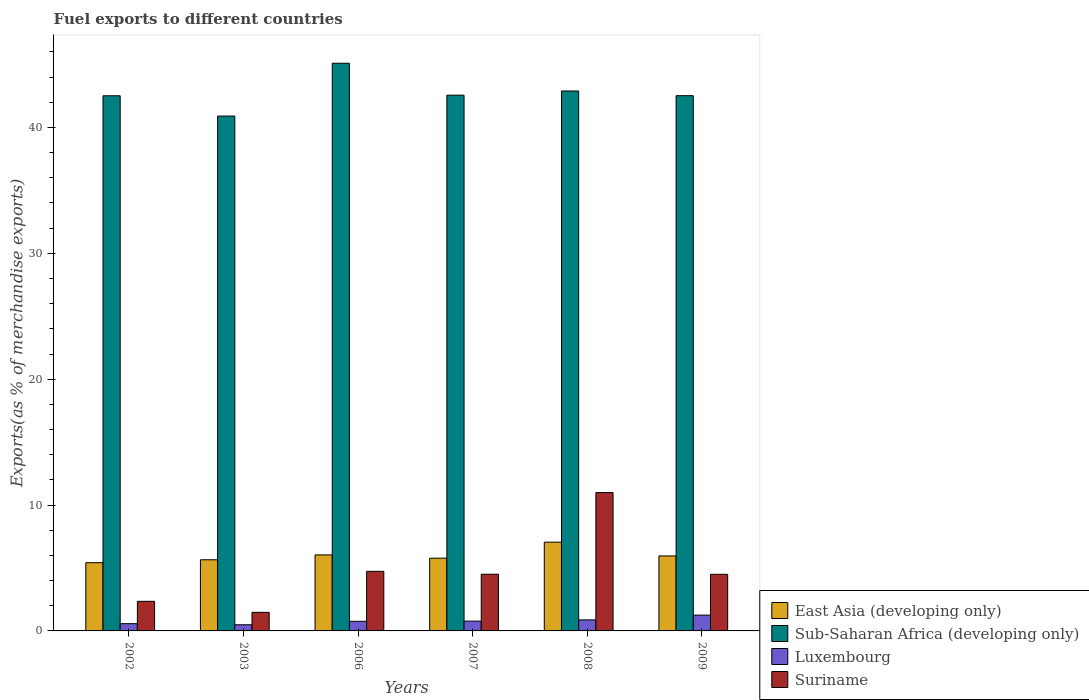Are the number of bars per tick equal to the number of legend labels?
Make the answer very short. Yes. Are the number of bars on each tick of the X-axis equal?
Keep it short and to the point. Yes. How many bars are there on the 1st tick from the right?
Provide a short and direct response. 4. What is the label of the 5th group of bars from the left?
Offer a very short reply. 2008. What is the percentage of exports to different countries in Sub-Saharan Africa (developing only) in 2006?
Offer a terse response. 45.1. Across all years, what is the maximum percentage of exports to different countries in East Asia (developing only)?
Make the answer very short. 7.05. Across all years, what is the minimum percentage of exports to different countries in Sub-Saharan Africa (developing only)?
Make the answer very short. 40.9. In which year was the percentage of exports to different countries in Luxembourg minimum?
Your answer should be very brief. 2003. What is the total percentage of exports to different countries in Suriname in the graph?
Offer a very short reply. 28.55. What is the difference between the percentage of exports to different countries in Suriname in 2003 and that in 2007?
Offer a very short reply. -3.03. What is the difference between the percentage of exports to different countries in Suriname in 2003 and the percentage of exports to different countries in Sub-Saharan Africa (developing only) in 2009?
Keep it short and to the point. -41.05. What is the average percentage of exports to different countries in Sub-Saharan Africa (developing only) per year?
Give a very brief answer. 42.75. In the year 2007, what is the difference between the percentage of exports to different countries in East Asia (developing only) and percentage of exports to different countries in Sub-Saharan Africa (developing only)?
Provide a succinct answer. -36.78. What is the ratio of the percentage of exports to different countries in Suriname in 2007 to that in 2008?
Give a very brief answer. 0.41. What is the difference between the highest and the second highest percentage of exports to different countries in Suriname?
Your response must be concise. 6.26. What is the difference between the highest and the lowest percentage of exports to different countries in Suriname?
Keep it short and to the point. 9.51. In how many years, is the percentage of exports to different countries in Suriname greater than the average percentage of exports to different countries in Suriname taken over all years?
Provide a succinct answer. 1. Is it the case that in every year, the sum of the percentage of exports to different countries in Luxembourg and percentage of exports to different countries in Suriname is greater than the sum of percentage of exports to different countries in East Asia (developing only) and percentage of exports to different countries in Sub-Saharan Africa (developing only)?
Ensure brevity in your answer.  No. What does the 1st bar from the left in 2008 represents?
Offer a terse response. East Asia (developing only). What does the 3rd bar from the right in 2007 represents?
Provide a succinct answer. Sub-Saharan Africa (developing only). How many bars are there?
Ensure brevity in your answer.  24. How many years are there in the graph?
Offer a terse response. 6. Are the values on the major ticks of Y-axis written in scientific E-notation?
Ensure brevity in your answer.  No. Does the graph contain any zero values?
Provide a succinct answer. No. Does the graph contain grids?
Make the answer very short. No. Where does the legend appear in the graph?
Make the answer very short. Bottom right. How many legend labels are there?
Your response must be concise. 4. How are the legend labels stacked?
Ensure brevity in your answer.  Vertical. What is the title of the graph?
Provide a short and direct response. Fuel exports to different countries. Does "Mexico" appear as one of the legend labels in the graph?
Give a very brief answer. No. What is the label or title of the X-axis?
Offer a very short reply. Years. What is the label or title of the Y-axis?
Give a very brief answer. Exports(as % of merchandise exports). What is the Exports(as % of merchandise exports) in East Asia (developing only) in 2002?
Your answer should be compact. 5.42. What is the Exports(as % of merchandise exports) of Sub-Saharan Africa (developing only) in 2002?
Provide a succinct answer. 42.51. What is the Exports(as % of merchandise exports) in Luxembourg in 2002?
Ensure brevity in your answer.  0.58. What is the Exports(as % of merchandise exports) of Suriname in 2002?
Provide a succinct answer. 2.35. What is the Exports(as % of merchandise exports) in East Asia (developing only) in 2003?
Make the answer very short. 5.65. What is the Exports(as % of merchandise exports) of Sub-Saharan Africa (developing only) in 2003?
Your answer should be compact. 40.9. What is the Exports(as % of merchandise exports) in Luxembourg in 2003?
Ensure brevity in your answer.  0.49. What is the Exports(as % of merchandise exports) in Suriname in 2003?
Your answer should be compact. 1.48. What is the Exports(as % of merchandise exports) of East Asia (developing only) in 2006?
Your response must be concise. 6.04. What is the Exports(as % of merchandise exports) of Sub-Saharan Africa (developing only) in 2006?
Provide a short and direct response. 45.1. What is the Exports(as % of merchandise exports) of Luxembourg in 2006?
Provide a short and direct response. 0.76. What is the Exports(as % of merchandise exports) of Suriname in 2006?
Your answer should be very brief. 4.73. What is the Exports(as % of merchandise exports) of East Asia (developing only) in 2007?
Offer a very short reply. 5.78. What is the Exports(as % of merchandise exports) in Sub-Saharan Africa (developing only) in 2007?
Offer a terse response. 42.56. What is the Exports(as % of merchandise exports) of Luxembourg in 2007?
Provide a succinct answer. 0.78. What is the Exports(as % of merchandise exports) in Suriname in 2007?
Your response must be concise. 4.5. What is the Exports(as % of merchandise exports) in East Asia (developing only) in 2008?
Ensure brevity in your answer.  7.05. What is the Exports(as % of merchandise exports) in Sub-Saharan Africa (developing only) in 2008?
Your answer should be compact. 42.89. What is the Exports(as % of merchandise exports) of Luxembourg in 2008?
Provide a short and direct response. 0.88. What is the Exports(as % of merchandise exports) of Suriname in 2008?
Keep it short and to the point. 10.99. What is the Exports(as % of merchandise exports) in East Asia (developing only) in 2009?
Keep it short and to the point. 5.96. What is the Exports(as % of merchandise exports) in Sub-Saharan Africa (developing only) in 2009?
Provide a short and direct response. 42.52. What is the Exports(as % of merchandise exports) in Luxembourg in 2009?
Your answer should be very brief. 1.26. What is the Exports(as % of merchandise exports) in Suriname in 2009?
Your response must be concise. 4.5. Across all years, what is the maximum Exports(as % of merchandise exports) of East Asia (developing only)?
Make the answer very short. 7.05. Across all years, what is the maximum Exports(as % of merchandise exports) of Sub-Saharan Africa (developing only)?
Provide a short and direct response. 45.1. Across all years, what is the maximum Exports(as % of merchandise exports) in Luxembourg?
Your response must be concise. 1.26. Across all years, what is the maximum Exports(as % of merchandise exports) in Suriname?
Provide a succinct answer. 10.99. Across all years, what is the minimum Exports(as % of merchandise exports) in East Asia (developing only)?
Provide a short and direct response. 5.42. Across all years, what is the minimum Exports(as % of merchandise exports) of Sub-Saharan Africa (developing only)?
Provide a short and direct response. 40.9. Across all years, what is the minimum Exports(as % of merchandise exports) of Luxembourg?
Keep it short and to the point. 0.49. Across all years, what is the minimum Exports(as % of merchandise exports) of Suriname?
Offer a very short reply. 1.48. What is the total Exports(as % of merchandise exports) in East Asia (developing only) in the graph?
Provide a succinct answer. 35.9. What is the total Exports(as % of merchandise exports) in Sub-Saharan Africa (developing only) in the graph?
Offer a very short reply. 256.49. What is the total Exports(as % of merchandise exports) of Luxembourg in the graph?
Offer a terse response. 4.74. What is the total Exports(as % of merchandise exports) of Suriname in the graph?
Ensure brevity in your answer.  28.55. What is the difference between the Exports(as % of merchandise exports) of East Asia (developing only) in 2002 and that in 2003?
Give a very brief answer. -0.23. What is the difference between the Exports(as % of merchandise exports) of Sub-Saharan Africa (developing only) in 2002 and that in 2003?
Make the answer very short. 1.61. What is the difference between the Exports(as % of merchandise exports) of Luxembourg in 2002 and that in 2003?
Provide a short and direct response. 0.09. What is the difference between the Exports(as % of merchandise exports) of Suriname in 2002 and that in 2003?
Your response must be concise. 0.87. What is the difference between the Exports(as % of merchandise exports) in East Asia (developing only) in 2002 and that in 2006?
Offer a terse response. -0.62. What is the difference between the Exports(as % of merchandise exports) in Sub-Saharan Africa (developing only) in 2002 and that in 2006?
Offer a terse response. -2.58. What is the difference between the Exports(as % of merchandise exports) of Luxembourg in 2002 and that in 2006?
Give a very brief answer. -0.19. What is the difference between the Exports(as % of merchandise exports) in Suriname in 2002 and that in 2006?
Provide a short and direct response. -2.38. What is the difference between the Exports(as % of merchandise exports) in East Asia (developing only) in 2002 and that in 2007?
Give a very brief answer. -0.36. What is the difference between the Exports(as % of merchandise exports) of Sub-Saharan Africa (developing only) in 2002 and that in 2007?
Offer a very short reply. -0.05. What is the difference between the Exports(as % of merchandise exports) of Luxembourg in 2002 and that in 2007?
Provide a succinct answer. -0.2. What is the difference between the Exports(as % of merchandise exports) in Suriname in 2002 and that in 2007?
Make the answer very short. -2.15. What is the difference between the Exports(as % of merchandise exports) in East Asia (developing only) in 2002 and that in 2008?
Ensure brevity in your answer.  -1.63. What is the difference between the Exports(as % of merchandise exports) of Sub-Saharan Africa (developing only) in 2002 and that in 2008?
Provide a short and direct response. -0.38. What is the difference between the Exports(as % of merchandise exports) of Luxembourg in 2002 and that in 2008?
Your response must be concise. -0.3. What is the difference between the Exports(as % of merchandise exports) in Suriname in 2002 and that in 2008?
Provide a short and direct response. -8.64. What is the difference between the Exports(as % of merchandise exports) in East Asia (developing only) in 2002 and that in 2009?
Offer a very short reply. -0.54. What is the difference between the Exports(as % of merchandise exports) of Sub-Saharan Africa (developing only) in 2002 and that in 2009?
Keep it short and to the point. -0.01. What is the difference between the Exports(as % of merchandise exports) of Luxembourg in 2002 and that in 2009?
Make the answer very short. -0.68. What is the difference between the Exports(as % of merchandise exports) in Suriname in 2002 and that in 2009?
Make the answer very short. -2.15. What is the difference between the Exports(as % of merchandise exports) of East Asia (developing only) in 2003 and that in 2006?
Your response must be concise. -0.39. What is the difference between the Exports(as % of merchandise exports) of Sub-Saharan Africa (developing only) in 2003 and that in 2006?
Provide a succinct answer. -4.2. What is the difference between the Exports(as % of merchandise exports) of Luxembourg in 2003 and that in 2006?
Offer a very short reply. -0.28. What is the difference between the Exports(as % of merchandise exports) of Suriname in 2003 and that in 2006?
Offer a very short reply. -3.26. What is the difference between the Exports(as % of merchandise exports) in East Asia (developing only) in 2003 and that in 2007?
Offer a terse response. -0.13. What is the difference between the Exports(as % of merchandise exports) in Sub-Saharan Africa (developing only) in 2003 and that in 2007?
Provide a short and direct response. -1.66. What is the difference between the Exports(as % of merchandise exports) in Luxembourg in 2003 and that in 2007?
Give a very brief answer. -0.29. What is the difference between the Exports(as % of merchandise exports) in Suriname in 2003 and that in 2007?
Ensure brevity in your answer.  -3.03. What is the difference between the Exports(as % of merchandise exports) of East Asia (developing only) in 2003 and that in 2008?
Offer a terse response. -1.4. What is the difference between the Exports(as % of merchandise exports) in Sub-Saharan Africa (developing only) in 2003 and that in 2008?
Offer a terse response. -1.99. What is the difference between the Exports(as % of merchandise exports) of Luxembourg in 2003 and that in 2008?
Your answer should be very brief. -0.39. What is the difference between the Exports(as % of merchandise exports) in Suriname in 2003 and that in 2008?
Give a very brief answer. -9.51. What is the difference between the Exports(as % of merchandise exports) in East Asia (developing only) in 2003 and that in 2009?
Offer a terse response. -0.3. What is the difference between the Exports(as % of merchandise exports) in Sub-Saharan Africa (developing only) in 2003 and that in 2009?
Your response must be concise. -1.62. What is the difference between the Exports(as % of merchandise exports) of Luxembourg in 2003 and that in 2009?
Provide a short and direct response. -0.77. What is the difference between the Exports(as % of merchandise exports) of Suriname in 2003 and that in 2009?
Give a very brief answer. -3.02. What is the difference between the Exports(as % of merchandise exports) of East Asia (developing only) in 2006 and that in 2007?
Your response must be concise. 0.26. What is the difference between the Exports(as % of merchandise exports) of Sub-Saharan Africa (developing only) in 2006 and that in 2007?
Ensure brevity in your answer.  2.54. What is the difference between the Exports(as % of merchandise exports) in Luxembourg in 2006 and that in 2007?
Your response must be concise. -0.01. What is the difference between the Exports(as % of merchandise exports) in Suriname in 2006 and that in 2007?
Provide a short and direct response. 0.23. What is the difference between the Exports(as % of merchandise exports) of East Asia (developing only) in 2006 and that in 2008?
Your answer should be compact. -1.01. What is the difference between the Exports(as % of merchandise exports) of Sub-Saharan Africa (developing only) in 2006 and that in 2008?
Offer a very short reply. 2.2. What is the difference between the Exports(as % of merchandise exports) in Luxembourg in 2006 and that in 2008?
Offer a very short reply. -0.11. What is the difference between the Exports(as % of merchandise exports) of Suriname in 2006 and that in 2008?
Your answer should be very brief. -6.26. What is the difference between the Exports(as % of merchandise exports) of East Asia (developing only) in 2006 and that in 2009?
Give a very brief answer. 0.08. What is the difference between the Exports(as % of merchandise exports) of Sub-Saharan Africa (developing only) in 2006 and that in 2009?
Offer a very short reply. 2.58. What is the difference between the Exports(as % of merchandise exports) of Luxembourg in 2006 and that in 2009?
Ensure brevity in your answer.  -0.49. What is the difference between the Exports(as % of merchandise exports) in Suriname in 2006 and that in 2009?
Keep it short and to the point. 0.24. What is the difference between the Exports(as % of merchandise exports) in East Asia (developing only) in 2007 and that in 2008?
Make the answer very short. -1.27. What is the difference between the Exports(as % of merchandise exports) in Sub-Saharan Africa (developing only) in 2007 and that in 2008?
Give a very brief answer. -0.33. What is the difference between the Exports(as % of merchandise exports) in Luxembourg in 2007 and that in 2008?
Your answer should be compact. -0.1. What is the difference between the Exports(as % of merchandise exports) in Suriname in 2007 and that in 2008?
Provide a short and direct response. -6.49. What is the difference between the Exports(as % of merchandise exports) of East Asia (developing only) in 2007 and that in 2009?
Offer a very short reply. -0.18. What is the difference between the Exports(as % of merchandise exports) of Sub-Saharan Africa (developing only) in 2007 and that in 2009?
Make the answer very short. 0.04. What is the difference between the Exports(as % of merchandise exports) in Luxembourg in 2007 and that in 2009?
Your answer should be very brief. -0.48. What is the difference between the Exports(as % of merchandise exports) of Suriname in 2007 and that in 2009?
Keep it short and to the point. 0.01. What is the difference between the Exports(as % of merchandise exports) of East Asia (developing only) in 2008 and that in 2009?
Keep it short and to the point. 1.1. What is the difference between the Exports(as % of merchandise exports) in Sub-Saharan Africa (developing only) in 2008 and that in 2009?
Make the answer very short. 0.37. What is the difference between the Exports(as % of merchandise exports) in Luxembourg in 2008 and that in 2009?
Offer a terse response. -0.38. What is the difference between the Exports(as % of merchandise exports) in Suriname in 2008 and that in 2009?
Your answer should be compact. 6.49. What is the difference between the Exports(as % of merchandise exports) in East Asia (developing only) in 2002 and the Exports(as % of merchandise exports) in Sub-Saharan Africa (developing only) in 2003?
Keep it short and to the point. -35.48. What is the difference between the Exports(as % of merchandise exports) in East Asia (developing only) in 2002 and the Exports(as % of merchandise exports) in Luxembourg in 2003?
Your response must be concise. 4.93. What is the difference between the Exports(as % of merchandise exports) of East Asia (developing only) in 2002 and the Exports(as % of merchandise exports) of Suriname in 2003?
Your response must be concise. 3.94. What is the difference between the Exports(as % of merchandise exports) in Sub-Saharan Africa (developing only) in 2002 and the Exports(as % of merchandise exports) in Luxembourg in 2003?
Provide a short and direct response. 42.03. What is the difference between the Exports(as % of merchandise exports) in Sub-Saharan Africa (developing only) in 2002 and the Exports(as % of merchandise exports) in Suriname in 2003?
Provide a succinct answer. 41.04. What is the difference between the Exports(as % of merchandise exports) in Luxembourg in 2002 and the Exports(as % of merchandise exports) in Suriname in 2003?
Make the answer very short. -0.9. What is the difference between the Exports(as % of merchandise exports) in East Asia (developing only) in 2002 and the Exports(as % of merchandise exports) in Sub-Saharan Africa (developing only) in 2006?
Keep it short and to the point. -39.68. What is the difference between the Exports(as % of merchandise exports) of East Asia (developing only) in 2002 and the Exports(as % of merchandise exports) of Luxembourg in 2006?
Your answer should be compact. 4.66. What is the difference between the Exports(as % of merchandise exports) in East Asia (developing only) in 2002 and the Exports(as % of merchandise exports) in Suriname in 2006?
Keep it short and to the point. 0.69. What is the difference between the Exports(as % of merchandise exports) of Sub-Saharan Africa (developing only) in 2002 and the Exports(as % of merchandise exports) of Luxembourg in 2006?
Give a very brief answer. 41.75. What is the difference between the Exports(as % of merchandise exports) of Sub-Saharan Africa (developing only) in 2002 and the Exports(as % of merchandise exports) of Suriname in 2006?
Your answer should be very brief. 37.78. What is the difference between the Exports(as % of merchandise exports) of Luxembourg in 2002 and the Exports(as % of merchandise exports) of Suriname in 2006?
Offer a terse response. -4.16. What is the difference between the Exports(as % of merchandise exports) in East Asia (developing only) in 2002 and the Exports(as % of merchandise exports) in Sub-Saharan Africa (developing only) in 2007?
Your answer should be very brief. -37.14. What is the difference between the Exports(as % of merchandise exports) in East Asia (developing only) in 2002 and the Exports(as % of merchandise exports) in Luxembourg in 2007?
Provide a succinct answer. 4.64. What is the difference between the Exports(as % of merchandise exports) in East Asia (developing only) in 2002 and the Exports(as % of merchandise exports) in Suriname in 2007?
Offer a very short reply. 0.92. What is the difference between the Exports(as % of merchandise exports) in Sub-Saharan Africa (developing only) in 2002 and the Exports(as % of merchandise exports) in Luxembourg in 2007?
Ensure brevity in your answer.  41.74. What is the difference between the Exports(as % of merchandise exports) in Sub-Saharan Africa (developing only) in 2002 and the Exports(as % of merchandise exports) in Suriname in 2007?
Provide a short and direct response. 38.01. What is the difference between the Exports(as % of merchandise exports) of Luxembourg in 2002 and the Exports(as % of merchandise exports) of Suriname in 2007?
Keep it short and to the point. -3.93. What is the difference between the Exports(as % of merchandise exports) of East Asia (developing only) in 2002 and the Exports(as % of merchandise exports) of Sub-Saharan Africa (developing only) in 2008?
Offer a very short reply. -37.47. What is the difference between the Exports(as % of merchandise exports) of East Asia (developing only) in 2002 and the Exports(as % of merchandise exports) of Luxembourg in 2008?
Ensure brevity in your answer.  4.54. What is the difference between the Exports(as % of merchandise exports) of East Asia (developing only) in 2002 and the Exports(as % of merchandise exports) of Suriname in 2008?
Offer a terse response. -5.57. What is the difference between the Exports(as % of merchandise exports) in Sub-Saharan Africa (developing only) in 2002 and the Exports(as % of merchandise exports) in Luxembourg in 2008?
Offer a very short reply. 41.64. What is the difference between the Exports(as % of merchandise exports) of Sub-Saharan Africa (developing only) in 2002 and the Exports(as % of merchandise exports) of Suriname in 2008?
Give a very brief answer. 31.52. What is the difference between the Exports(as % of merchandise exports) of Luxembourg in 2002 and the Exports(as % of merchandise exports) of Suriname in 2008?
Your answer should be very brief. -10.41. What is the difference between the Exports(as % of merchandise exports) in East Asia (developing only) in 2002 and the Exports(as % of merchandise exports) in Sub-Saharan Africa (developing only) in 2009?
Ensure brevity in your answer.  -37.1. What is the difference between the Exports(as % of merchandise exports) of East Asia (developing only) in 2002 and the Exports(as % of merchandise exports) of Luxembourg in 2009?
Your response must be concise. 4.16. What is the difference between the Exports(as % of merchandise exports) of East Asia (developing only) in 2002 and the Exports(as % of merchandise exports) of Suriname in 2009?
Give a very brief answer. 0.92. What is the difference between the Exports(as % of merchandise exports) of Sub-Saharan Africa (developing only) in 2002 and the Exports(as % of merchandise exports) of Luxembourg in 2009?
Your answer should be very brief. 41.26. What is the difference between the Exports(as % of merchandise exports) of Sub-Saharan Africa (developing only) in 2002 and the Exports(as % of merchandise exports) of Suriname in 2009?
Offer a terse response. 38.02. What is the difference between the Exports(as % of merchandise exports) of Luxembourg in 2002 and the Exports(as % of merchandise exports) of Suriname in 2009?
Provide a succinct answer. -3.92. What is the difference between the Exports(as % of merchandise exports) of East Asia (developing only) in 2003 and the Exports(as % of merchandise exports) of Sub-Saharan Africa (developing only) in 2006?
Keep it short and to the point. -39.45. What is the difference between the Exports(as % of merchandise exports) in East Asia (developing only) in 2003 and the Exports(as % of merchandise exports) in Luxembourg in 2006?
Your answer should be compact. 4.89. What is the difference between the Exports(as % of merchandise exports) in East Asia (developing only) in 2003 and the Exports(as % of merchandise exports) in Suriname in 2006?
Your answer should be compact. 0.92. What is the difference between the Exports(as % of merchandise exports) of Sub-Saharan Africa (developing only) in 2003 and the Exports(as % of merchandise exports) of Luxembourg in 2006?
Your response must be concise. 40.14. What is the difference between the Exports(as % of merchandise exports) in Sub-Saharan Africa (developing only) in 2003 and the Exports(as % of merchandise exports) in Suriname in 2006?
Offer a terse response. 36.17. What is the difference between the Exports(as % of merchandise exports) of Luxembourg in 2003 and the Exports(as % of merchandise exports) of Suriname in 2006?
Your response must be concise. -4.25. What is the difference between the Exports(as % of merchandise exports) of East Asia (developing only) in 2003 and the Exports(as % of merchandise exports) of Sub-Saharan Africa (developing only) in 2007?
Offer a very short reply. -36.91. What is the difference between the Exports(as % of merchandise exports) in East Asia (developing only) in 2003 and the Exports(as % of merchandise exports) in Luxembourg in 2007?
Your answer should be very brief. 4.87. What is the difference between the Exports(as % of merchandise exports) of East Asia (developing only) in 2003 and the Exports(as % of merchandise exports) of Suriname in 2007?
Provide a succinct answer. 1.15. What is the difference between the Exports(as % of merchandise exports) in Sub-Saharan Africa (developing only) in 2003 and the Exports(as % of merchandise exports) in Luxembourg in 2007?
Offer a very short reply. 40.12. What is the difference between the Exports(as % of merchandise exports) of Sub-Saharan Africa (developing only) in 2003 and the Exports(as % of merchandise exports) of Suriname in 2007?
Give a very brief answer. 36.4. What is the difference between the Exports(as % of merchandise exports) of Luxembourg in 2003 and the Exports(as % of merchandise exports) of Suriname in 2007?
Offer a terse response. -4.02. What is the difference between the Exports(as % of merchandise exports) in East Asia (developing only) in 2003 and the Exports(as % of merchandise exports) in Sub-Saharan Africa (developing only) in 2008?
Provide a short and direct response. -37.24. What is the difference between the Exports(as % of merchandise exports) of East Asia (developing only) in 2003 and the Exports(as % of merchandise exports) of Luxembourg in 2008?
Offer a very short reply. 4.78. What is the difference between the Exports(as % of merchandise exports) in East Asia (developing only) in 2003 and the Exports(as % of merchandise exports) in Suriname in 2008?
Give a very brief answer. -5.34. What is the difference between the Exports(as % of merchandise exports) of Sub-Saharan Africa (developing only) in 2003 and the Exports(as % of merchandise exports) of Luxembourg in 2008?
Ensure brevity in your answer.  40.03. What is the difference between the Exports(as % of merchandise exports) of Sub-Saharan Africa (developing only) in 2003 and the Exports(as % of merchandise exports) of Suriname in 2008?
Your response must be concise. 29.91. What is the difference between the Exports(as % of merchandise exports) in Luxembourg in 2003 and the Exports(as % of merchandise exports) in Suriname in 2008?
Give a very brief answer. -10.5. What is the difference between the Exports(as % of merchandise exports) in East Asia (developing only) in 2003 and the Exports(as % of merchandise exports) in Sub-Saharan Africa (developing only) in 2009?
Keep it short and to the point. -36.87. What is the difference between the Exports(as % of merchandise exports) of East Asia (developing only) in 2003 and the Exports(as % of merchandise exports) of Luxembourg in 2009?
Your response must be concise. 4.4. What is the difference between the Exports(as % of merchandise exports) in East Asia (developing only) in 2003 and the Exports(as % of merchandise exports) in Suriname in 2009?
Your answer should be compact. 1.15. What is the difference between the Exports(as % of merchandise exports) of Sub-Saharan Africa (developing only) in 2003 and the Exports(as % of merchandise exports) of Luxembourg in 2009?
Offer a terse response. 39.65. What is the difference between the Exports(as % of merchandise exports) in Sub-Saharan Africa (developing only) in 2003 and the Exports(as % of merchandise exports) in Suriname in 2009?
Give a very brief answer. 36.41. What is the difference between the Exports(as % of merchandise exports) of Luxembourg in 2003 and the Exports(as % of merchandise exports) of Suriname in 2009?
Your response must be concise. -4.01. What is the difference between the Exports(as % of merchandise exports) in East Asia (developing only) in 2006 and the Exports(as % of merchandise exports) in Sub-Saharan Africa (developing only) in 2007?
Your response must be concise. -36.52. What is the difference between the Exports(as % of merchandise exports) of East Asia (developing only) in 2006 and the Exports(as % of merchandise exports) of Luxembourg in 2007?
Provide a succinct answer. 5.26. What is the difference between the Exports(as % of merchandise exports) of East Asia (developing only) in 2006 and the Exports(as % of merchandise exports) of Suriname in 2007?
Ensure brevity in your answer.  1.54. What is the difference between the Exports(as % of merchandise exports) in Sub-Saharan Africa (developing only) in 2006 and the Exports(as % of merchandise exports) in Luxembourg in 2007?
Give a very brief answer. 44.32. What is the difference between the Exports(as % of merchandise exports) of Sub-Saharan Africa (developing only) in 2006 and the Exports(as % of merchandise exports) of Suriname in 2007?
Your response must be concise. 40.59. What is the difference between the Exports(as % of merchandise exports) in Luxembourg in 2006 and the Exports(as % of merchandise exports) in Suriname in 2007?
Your answer should be compact. -3.74. What is the difference between the Exports(as % of merchandise exports) in East Asia (developing only) in 2006 and the Exports(as % of merchandise exports) in Sub-Saharan Africa (developing only) in 2008?
Offer a very short reply. -36.86. What is the difference between the Exports(as % of merchandise exports) of East Asia (developing only) in 2006 and the Exports(as % of merchandise exports) of Luxembourg in 2008?
Provide a succinct answer. 5.16. What is the difference between the Exports(as % of merchandise exports) in East Asia (developing only) in 2006 and the Exports(as % of merchandise exports) in Suriname in 2008?
Make the answer very short. -4.95. What is the difference between the Exports(as % of merchandise exports) in Sub-Saharan Africa (developing only) in 2006 and the Exports(as % of merchandise exports) in Luxembourg in 2008?
Your answer should be very brief. 44.22. What is the difference between the Exports(as % of merchandise exports) in Sub-Saharan Africa (developing only) in 2006 and the Exports(as % of merchandise exports) in Suriname in 2008?
Ensure brevity in your answer.  34.11. What is the difference between the Exports(as % of merchandise exports) of Luxembourg in 2006 and the Exports(as % of merchandise exports) of Suriname in 2008?
Offer a terse response. -10.23. What is the difference between the Exports(as % of merchandise exports) of East Asia (developing only) in 2006 and the Exports(as % of merchandise exports) of Sub-Saharan Africa (developing only) in 2009?
Your answer should be compact. -36.48. What is the difference between the Exports(as % of merchandise exports) of East Asia (developing only) in 2006 and the Exports(as % of merchandise exports) of Luxembourg in 2009?
Give a very brief answer. 4.78. What is the difference between the Exports(as % of merchandise exports) in East Asia (developing only) in 2006 and the Exports(as % of merchandise exports) in Suriname in 2009?
Your answer should be compact. 1.54. What is the difference between the Exports(as % of merchandise exports) in Sub-Saharan Africa (developing only) in 2006 and the Exports(as % of merchandise exports) in Luxembourg in 2009?
Keep it short and to the point. 43.84. What is the difference between the Exports(as % of merchandise exports) of Sub-Saharan Africa (developing only) in 2006 and the Exports(as % of merchandise exports) of Suriname in 2009?
Offer a very short reply. 40.6. What is the difference between the Exports(as % of merchandise exports) of Luxembourg in 2006 and the Exports(as % of merchandise exports) of Suriname in 2009?
Give a very brief answer. -3.73. What is the difference between the Exports(as % of merchandise exports) of East Asia (developing only) in 2007 and the Exports(as % of merchandise exports) of Sub-Saharan Africa (developing only) in 2008?
Provide a short and direct response. -37.12. What is the difference between the Exports(as % of merchandise exports) in East Asia (developing only) in 2007 and the Exports(as % of merchandise exports) in Luxembourg in 2008?
Make the answer very short. 4.9. What is the difference between the Exports(as % of merchandise exports) in East Asia (developing only) in 2007 and the Exports(as % of merchandise exports) in Suriname in 2008?
Offer a terse response. -5.21. What is the difference between the Exports(as % of merchandise exports) of Sub-Saharan Africa (developing only) in 2007 and the Exports(as % of merchandise exports) of Luxembourg in 2008?
Provide a short and direct response. 41.69. What is the difference between the Exports(as % of merchandise exports) in Sub-Saharan Africa (developing only) in 2007 and the Exports(as % of merchandise exports) in Suriname in 2008?
Your answer should be very brief. 31.57. What is the difference between the Exports(as % of merchandise exports) of Luxembourg in 2007 and the Exports(as % of merchandise exports) of Suriname in 2008?
Your response must be concise. -10.21. What is the difference between the Exports(as % of merchandise exports) in East Asia (developing only) in 2007 and the Exports(as % of merchandise exports) in Sub-Saharan Africa (developing only) in 2009?
Make the answer very short. -36.74. What is the difference between the Exports(as % of merchandise exports) of East Asia (developing only) in 2007 and the Exports(as % of merchandise exports) of Luxembourg in 2009?
Offer a very short reply. 4.52. What is the difference between the Exports(as % of merchandise exports) in East Asia (developing only) in 2007 and the Exports(as % of merchandise exports) in Suriname in 2009?
Offer a terse response. 1.28. What is the difference between the Exports(as % of merchandise exports) of Sub-Saharan Africa (developing only) in 2007 and the Exports(as % of merchandise exports) of Luxembourg in 2009?
Provide a succinct answer. 41.31. What is the difference between the Exports(as % of merchandise exports) of Sub-Saharan Africa (developing only) in 2007 and the Exports(as % of merchandise exports) of Suriname in 2009?
Give a very brief answer. 38.06. What is the difference between the Exports(as % of merchandise exports) of Luxembourg in 2007 and the Exports(as % of merchandise exports) of Suriname in 2009?
Ensure brevity in your answer.  -3.72. What is the difference between the Exports(as % of merchandise exports) of East Asia (developing only) in 2008 and the Exports(as % of merchandise exports) of Sub-Saharan Africa (developing only) in 2009?
Your answer should be compact. -35.47. What is the difference between the Exports(as % of merchandise exports) of East Asia (developing only) in 2008 and the Exports(as % of merchandise exports) of Luxembourg in 2009?
Provide a succinct answer. 5.8. What is the difference between the Exports(as % of merchandise exports) in East Asia (developing only) in 2008 and the Exports(as % of merchandise exports) in Suriname in 2009?
Keep it short and to the point. 2.56. What is the difference between the Exports(as % of merchandise exports) of Sub-Saharan Africa (developing only) in 2008 and the Exports(as % of merchandise exports) of Luxembourg in 2009?
Your answer should be compact. 41.64. What is the difference between the Exports(as % of merchandise exports) of Sub-Saharan Africa (developing only) in 2008 and the Exports(as % of merchandise exports) of Suriname in 2009?
Make the answer very short. 38.4. What is the difference between the Exports(as % of merchandise exports) in Luxembourg in 2008 and the Exports(as % of merchandise exports) in Suriname in 2009?
Your answer should be very brief. -3.62. What is the average Exports(as % of merchandise exports) of East Asia (developing only) per year?
Provide a succinct answer. 5.98. What is the average Exports(as % of merchandise exports) of Sub-Saharan Africa (developing only) per year?
Your answer should be compact. 42.75. What is the average Exports(as % of merchandise exports) of Luxembourg per year?
Offer a terse response. 0.79. What is the average Exports(as % of merchandise exports) in Suriname per year?
Ensure brevity in your answer.  4.76. In the year 2002, what is the difference between the Exports(as % of merchandise exports) in East Asia (developing only) and Exports(as % of merchandise exports) in Sub-Saharan Africa (developing only)?
Keep it short and to the point. -37.1. In the year 2002, what is the difference between the Exports(as % of merchandise exports) of East Asia (developing only) and Exports(as % of merchandise exports) of Luxembourg?
Give a very brief answer. 4.84. In the year 2002, what is the difference between the Exports(as % of merchandise exports) in East Asia (developing only) and Exports(as % of merchandise exports) in Suriname?
Your response must be concise. 3.07. In the year 2002, what is the difference between the Exports(as % of merchandise exports) in Sub-Saharan Africa (developing only) and Exports(as % of merchandise exports) in Luxembourg?
Give a very brief answer. 41.94. In the year 2002, what is the difference between the Exports(as % of merchandise exports) of Sub-Saharan Africa (developing only) and Exports(as % of merchandise exports) of Suriname?
Provide a succinct answer. 40.16. In the year 2002, what is the difference between the Exports(as % of merchandise exports) in Luxembourg and Exports(as % of merchandise exports) in Suriname?
Your answer should be very brief. -1.77. In the year 2003, what is the difference between the Exports(as % of merchandise exports) of East Asia (developing only) and Exports(as % of merchandise exports) of Sub-Saharan Africa (developing only)?
Give a very brief answer. -35.25. In the year 2003, what is the difference between the Exports(as % of merchandise exports) in East Asia (developing only) and Exports(as % of merchandise exports) in Luxembourg?
Provide a succinct answer. 5.16. In the year 2003, what is the difference between the Exports(as % of merchandise exports) of East Asia (developing only) and Exports(as % of merchandise exports) of Suriname?
Make the answer very short. 4.18. In the year 2003, what is the difference between the Exports(as % of merchandise exports) of Sub-Saharan Africa (developing only) and Exports(as % of merchandise exports) of Luxembourg?
Your answer should be compact. 40.41. In the year 2003, what is the difference between the Exports(as % of merchandise exports) in Sub-Saharan Africa (developing only) and Exports(as % of merchandise exports) in Suriname?
Provide a short and direct response. 39.43. In the year 2003, what is the difference between the Exports(as % of merchandise exports) of Luxembourg and Exports(as % of merchandise exports) of Suriname?
Make the answer very short. -0.99. In the year 2006, what is the difference between the Exports(as % of merchandise exports) of East Asia (developing only) and Exports(as % of merchandise exports) of Sub-Saharan Africa (developing only)?
Your response must be concise. -39.06. In the year 2006, what is the difference between the Exports(as % of merchandise exports) in East Asia (developing only) and Exports(as % of merchandise exports) in Luxembourg?
Make the answer very short. 5.27. In the year 2006, what is the difference between the Exports(as % of merchandise exports) of East Asia (developing only) and Exports(as % of merchandise exports) of Suriname?
Offer a very short reply. 1.3. In the year 2006, what is the difference between the Exports(as % of merchandise exports) of Sub-Saharan Africa (developing only) and Exports(as % of merchandise exports) of Luxembourg?
Your answer should be very brief. 44.33. In the year 2006, what is the difference between the Exports(as % of merchandise exports) in Sub-Saharan Africa (developing only) and Exports(as % of merchandise exports) in Suriname?
Offer a very short reply. 40.36. In the year 2006, what is the difference between the Exports(as % of merchandise exports) of Luxembourg and Exports(as % of merchandise exports) of Suriname?
Ensure brevity in your answer.  -3.97. In the year 2007, what is the difference between the Exports(as % of merchandise exports) of East Asia (developing only) and Exports(as % of merchandise exports) of Sub-Saharan Africa (developing only)?
Keep it short and to the point. -36.78. In the year 2007, what is the difference between the Exports(as % of merchandise exports) in East Asia (developing only) and Exports(as % of merchandise exports) in Luxembourg?
Provide a short and direct response. 5. In the year 2007, what is the difference between the Exports(as % of merchandise exports) of East Asia (developing only) and Exports(as % of merchandise exports) of Suriname?
Your answer should be very brief. 1.28. In the year 2007, what is the difference between the Exports(as % of merchandise exports) of Sub-Saharan Africa (developing only) and Exports(as % of merchandise exports) of Luxembourg?
Give a very brief answer. 41.78. In the year 2007, what is the difference between the Exports(as % of merchandise exports) of Sub-Saharan Africa (developing only) and Exports(as % of merchandise exports) of Suriname?
Make the answer very short. 38.06. In the year 2007, what is the difference between the Exports(as % of merchandise exports) of Luxembourg and Exports(as % of merchandise exports) of Suriname?
Your response must be concise. -3.72. In the year 2008, what is the difference between the Exports(as % of merchandise exports) in East Asia (developing only) and Exports(as % of merchandise exports) in Sub-Saharan Africa (developing only)?
Your response must be concise. -35.84. In the year 2008, what is the difference between the Exports(as % of merchandise exports) in East Asia (developing only) and Exports(as % of merchandise exports) in Luxembourg?
Give a very brief answer. 6.18. In the year 2008, what is the difference between the Exports(as % of merchandise exports) of East Asia (developing only) and Exports(as % of merchandise exports) of Suriname?
Your answer should be compact. -3.94. In the year 2008, what is the difference between the Exports(as % of merchandise exports) in Sub-Saharan Africa (developing only) and Exports(as % of merchandise exports) in Luxembourg?
Make the answer very short. 42.02. In the year 2008, what is the difference between the Exports(as % of merchandise exports) of Sub-Saharan Africa (developing only) and Exports(as % of merchandise exports) of Suriname?
Give a very brief answer. 31.9. In the year 2008, what is the difference between the Exports(as % of merchandise exports) in Luxembourg and Exports(as % of merchandise exports) in Suriname?
Ensure brevity in your answer.  -10.11. In the year 2009, what is the difference between the Exports(as % of merchandise exports) in East Asia (developing only) and Exports(as % of merchandise exports) in Sub-Saharan Africa (developing only)?
Keep it short and to the point. -36.57. In the year 2009, what is the difference between the Exports(as % of merchandise exports) of East Asia (developing only) and Exports(as % of merchandise exports) of Luxembourg?
Offer a terse response. 4.7. In the year 2009, what is the difference between the Exports(as % of merchandise exports) of East Asia (developing only) and Exports(as % of merchandise exports) of Suriname?
Your answer should be compact. 1.46. In the year 2009, what is the difference between the Exports(as % of merchandise exports) in Sub-Saharan Africa (developing only) and Exports(as % of merchandise exports) in Luxembourg?
Provide a succinct answer. 41.27. In the year 2009, what is the difference between the Exports(as % of merchandise exports) in Sub-Saharan Africa (developing only) and Exports(as % of merchandise exports) in Suriname?
Offer a very short reply. 38.02. In the year 2009, what is the difference between the Exports(as % of merchandise exports) in Luxembourg and Exports(as % of merchandise exports) in Suriname?
Offer a terse response. -3.24. What is the ratio of the Exports(as % of merchandise exports) of East Asia (developing only) in 2002 to that in 2003?
Provide a succinct answer. 0.96. What is the ratio of the Exports(as % of merchandise exports) of Sub-Saharan Africa (developing only) in 2002 to that in 2003?
Make the answer very short. 1.04. What is the ratio of the Exports(as % of merchandise exports) of Luxembourg in 2002 to that in 2003?
Make the answer very short. 1.18. What is the ratio of the Exports(as % of merchandise exports) in Suriname in 2002 to that in 2003?
Your answer should be very brief. 1.59. What is the ratio of the Exports(as % of merchandise exports) in East Asia (developing only) in 2002 to that in 2006?
Give a very brief answer. 0.9. What is the ratio of the Exports(as % of merchandise exports) in Sub-Saharan Africa (developing only) in 2002 to that in 2006?
Provide a short and direct response. 0.94. What is the ratio of the Exports(as % of merchandise exports) in Luxembourg in 2002 to that in 2006?
Offer a terse response. 0.76. What is the ratio of the Exports(as % of merchandise exports) of Suriname in 2002 to that in 2006?
Your response must be concise. 0.5. What is the ratio of the Exports(as % of merchandise exports) in East Asia (developing only) in 2002 to that in 2007?
Keep it short and to the point. 0.94. What is the ratio of the Exports(as % of merchandise exports) in Sub-Saharan Africa (developing only) in 2002 to that in 2007?
Provide a short and direct response. 1. What is the ratio of the Exports(as % of merchandise exports) of Luxembourg in 2002 to that in 2007?
Give a very brief answer. 0.74. What is the ratio of the Exports(as % of merchandise exports) in Suriname in 2002 to that in 2007?
Provide a succinct answer. 0.52. What is the ratio of the Exports(as % of merchandise exports) in East Asia (developing only) in 2002 to that in 2008?
Give a very brief answer. 0.77. What is the ratio of the Exports(as % of merchandise exports) of Sub-Saharan Africa (developing only) in 2002 to that in 2008?
Your answer should be compact. 0.99. What is the ratio of the Exports(as % of merchandise exports) in Luxembourg in 2002 to that in 2008?
Make the answer very short. 0.66. What is the ratio of the Exports(as % of merchandise exports) in Suriname in 2002 to that in 2008?
Offer a very short reply. 0.21. What is the ratio of the Exports(as % of merchandise exports) of East Asia (developing only) in 2002 to that in 2009?
Provide a succinct answer. 0.91. What is the ratio of the Exports(as % of merchandise exports) of Luxembourg in 2002 to that in 2009?
Your answer should be very brief. 0.46. What is the ratio of the Exports(as % of merchandise exports) of Suriname in 2002 to that in 2009?
Your response must be concise. 0.52. What is the ratio of the Exports(as % of merchandise exports) in East Asia (developing only) in 2003 to that in 2006?
Your response must be concise. 0.94. What is the ratio of the Exports(as % of merchandise exports) in Sub-Saharan Africa (developing only) in 2003 to that in 2006?
Keep it short and to the point. 0.91. What is the ratio of the Exports(as % of merchandise exports) in Luxembourg in 2003 to that in 2006?
Make the answer very short. 0.64. What is the ratio of the Exports(as % of merchandise exports) in Suriname in 2003 to that in 2006?
Ensure brevity in your answer.  0.31. What is the ratio of the Exports(as % of merchandise exports) of East Asia (developing only) in 2003 to that in 2007?
Your answer should be very brief. 0.98. What is the ratio of the Exports(as % of merchandise exports) of Sub-Saharan Africa (developing only) in 2003 to that in 2007?
Make the answer very short. 0.96. What is the ratio of the Exports(as % of merchandise exports) of Luxembourg in 2003 to that in 2007?
Offer a terse response. 0.63. What is the ratio of the Exports(as % of merchandise exports) of Suriname in 2003 to that in 2007?
Your response must be concise. 0.33. What is the ratio of the Exports(as % of merchandise exports) of East Asia (developing only) in 2003 to that in 2008?
Your response must be concise. 0.8. What is the ratio of the Exports(as % of merchandise exports) in Sub-Saharan Africa (developing only) in 2003 to that in 2008?
Your response must be concise. 0.95. What is the ratio of the Exports(as % of merchandise exports) in Luxembourg in 2003 to that in 2008?
Ensure brevity in your answer.  0.56. What is the ratio of the Exports(as % of merchandise exports) of Suriname in 2003 to that in 2008?
Provide a short and direct response. 0.13. What is the ratio of the Exports(as % of merchandise exports) of East Asia (developing only) in 2003 to that in 2009?
Provide a short and direct response. 0.95. What is the ratio of the Exports(as % of merchandise exports) in Sub-Saharan Africa (developing only) in 2003 to that in 2009?
Your answer should be compact. 0.96. What is the ratio of the Exports(as % of merchandise exports) in Luxembourg in 2003 to that in 2009?
Give a very brief answer. 0.39. What is the ratio of the Exports(as % of merchandise exports) of Suriname in 2003 to that in 2009?
Offer a very short reply. 0.33. What is the ratio of the Exports(as % of merchandise exports) in East Asia (developing only) in 2006 to that in 2007?
Your response must be concise. 1.04. What is the ratio of the Exports(as % of merchandise exports) of Sub-Saharan Africa (developing only) in 2006 to that in 2007?
Keep it short and to the point. 1.06. What is the ratio of the Exports(as % of merchandise exports) of Luxembourg in 2006 to that in 2007?
Your response must be concise. 0.98. What is the ratio of the Exports(as % of merchandise exports) of Suriname in 2006 to that in 2007?
Keep it short and to the point. 1.05. What is the ratio of the Exports(as % of merchandise exports) in East Asia (developing only) in 2006 to that in 2008?
Your response must be concise. 0.86. What is the ratio of the Exports(as % of merchandise exports) of Sub-Saharan Africa (developing only) in 2006 to that in 2008?
Keep it short and to the point. 1.05. What is the ratio of the Exports(as % of merchandise exports) in Luxembourg in 2006 to that in 2008?
Offer a very short reply. 0.87. What is the ratio of the Exports(as % of merchandise exports) of Suriname in 2006 to that in 2008?
Provide a short and direct response. 0.43. What is the ratio of the Exports(as % of merchandise exports) in East Asia (developing only) in 2006 to that in 2009?
Provide a short and direct response. 1.01. What is the ratio of the Exports(as % of merchandise exports) of Sub-Saharan Africa (developing only) in 2006 to that in 2009?
Offer a terse response. 1.06. What is the ratio of the Exports(as % of merchandise exports) of Luxembourg in 2006 to that in 2009?
Provide a succinct answer. 0.61. What is the ratio of the Exports(as % of merchandise exports) of Suriname in 2006 to that in 2009?
Ensure brevity in your answer.  1.05. What is the ratio of the Exports(as % of merchandise exports) in East Asia (developing only) in 2007 to that in 2008?
Your answer should be very brief. 0.82. What is the ratio of the Exports(as % of merchandise exports) of Sub-Saharan Africa (developing only) in 2007 to that in 2008?
Offer a very short reply. 0.99. What is the ratio of the Exports(as % of merchandise exports) in Luxembourg in 2007 to that in 2008?
Your answer should be very brief. 0.89. What is the ratio of the Exports(as % of merchandise exports) of Suriname in 2007 to that in 2008?
Offer a terse response. 0.41. What is the ratio of the Exports(as % of merchandise exports) of East Asia (developing only) in 2007 to that in 2009?
Your answer should be compact. 0.97. What is the ratio of the Exports(as % of merchandise exports) of Sub-Saharan Africa (developing only) in 2007 to that in 2009?
Ensure brevity in your answer.  1. What is the ratio of the Exports(as % of merchandise exports) of Luxembourg in 2007 to that in 2009?
Offer a very short reply. 0.62. What is the ratio of the Exports(as % of merchandise exports) in East Asia (developing only) in 2008 to that in 2009?
Make the answer very short. 1.18. What is the ratio of the Exports(as % of merchandise exports) in Sub-Saharan Africa (developing only) in 2008 to that in 2009?
Provide a succinct answer. 1.01. What is the ratio of the Exports(as % of merchandise exports) in Luxembourg in 2008 to that in 2009?
Your answer should be compact. 0.7. What is the ratio of the Exports(as % of merchandise exports) in Suriname in 2008 to that in 2009?
Keep it short and to the point. 2.44. What is the difference between the highest and the second highest Exports(as % of merchandise exports) of East Asia (developing only)?
Give a very brief answer. 1.01. What is the difference between the highest and the second highest Exports(as % of merchandise exports) of Sub-Saharan Africa (developing only)?
Your answer should be very brief. 2.2. What is the difference between the highest and the second highest Exports(as % of merchandise exports) of Luxembourg?
Make the answer very short. 0.38. What is the difference between the highest and the second highest Exports(as % of merchandise exports) in Suriname?
Keep it short and to the point. 6.26. What is the difference between the highest and the lowest Exports(as % of merchandise exports) of East Asia (developing only)?
Your answer should be very brief. 1.63. What is the difference between the highest and the lowest Exports(as % of merchandise exports) of Sub-Saharan Africa (developing only)?
Keep it short and to the point. 4.2. What is the difference between the highest and the lowest Exports(as % of merchandise exports) in Luxembourg?
Ensure brevity in your answer.  0.77. What is the difference between the highest and the lowest Exports(as % of merchandise exports) in Suriname?
Your answer should be compact. 9.51. 